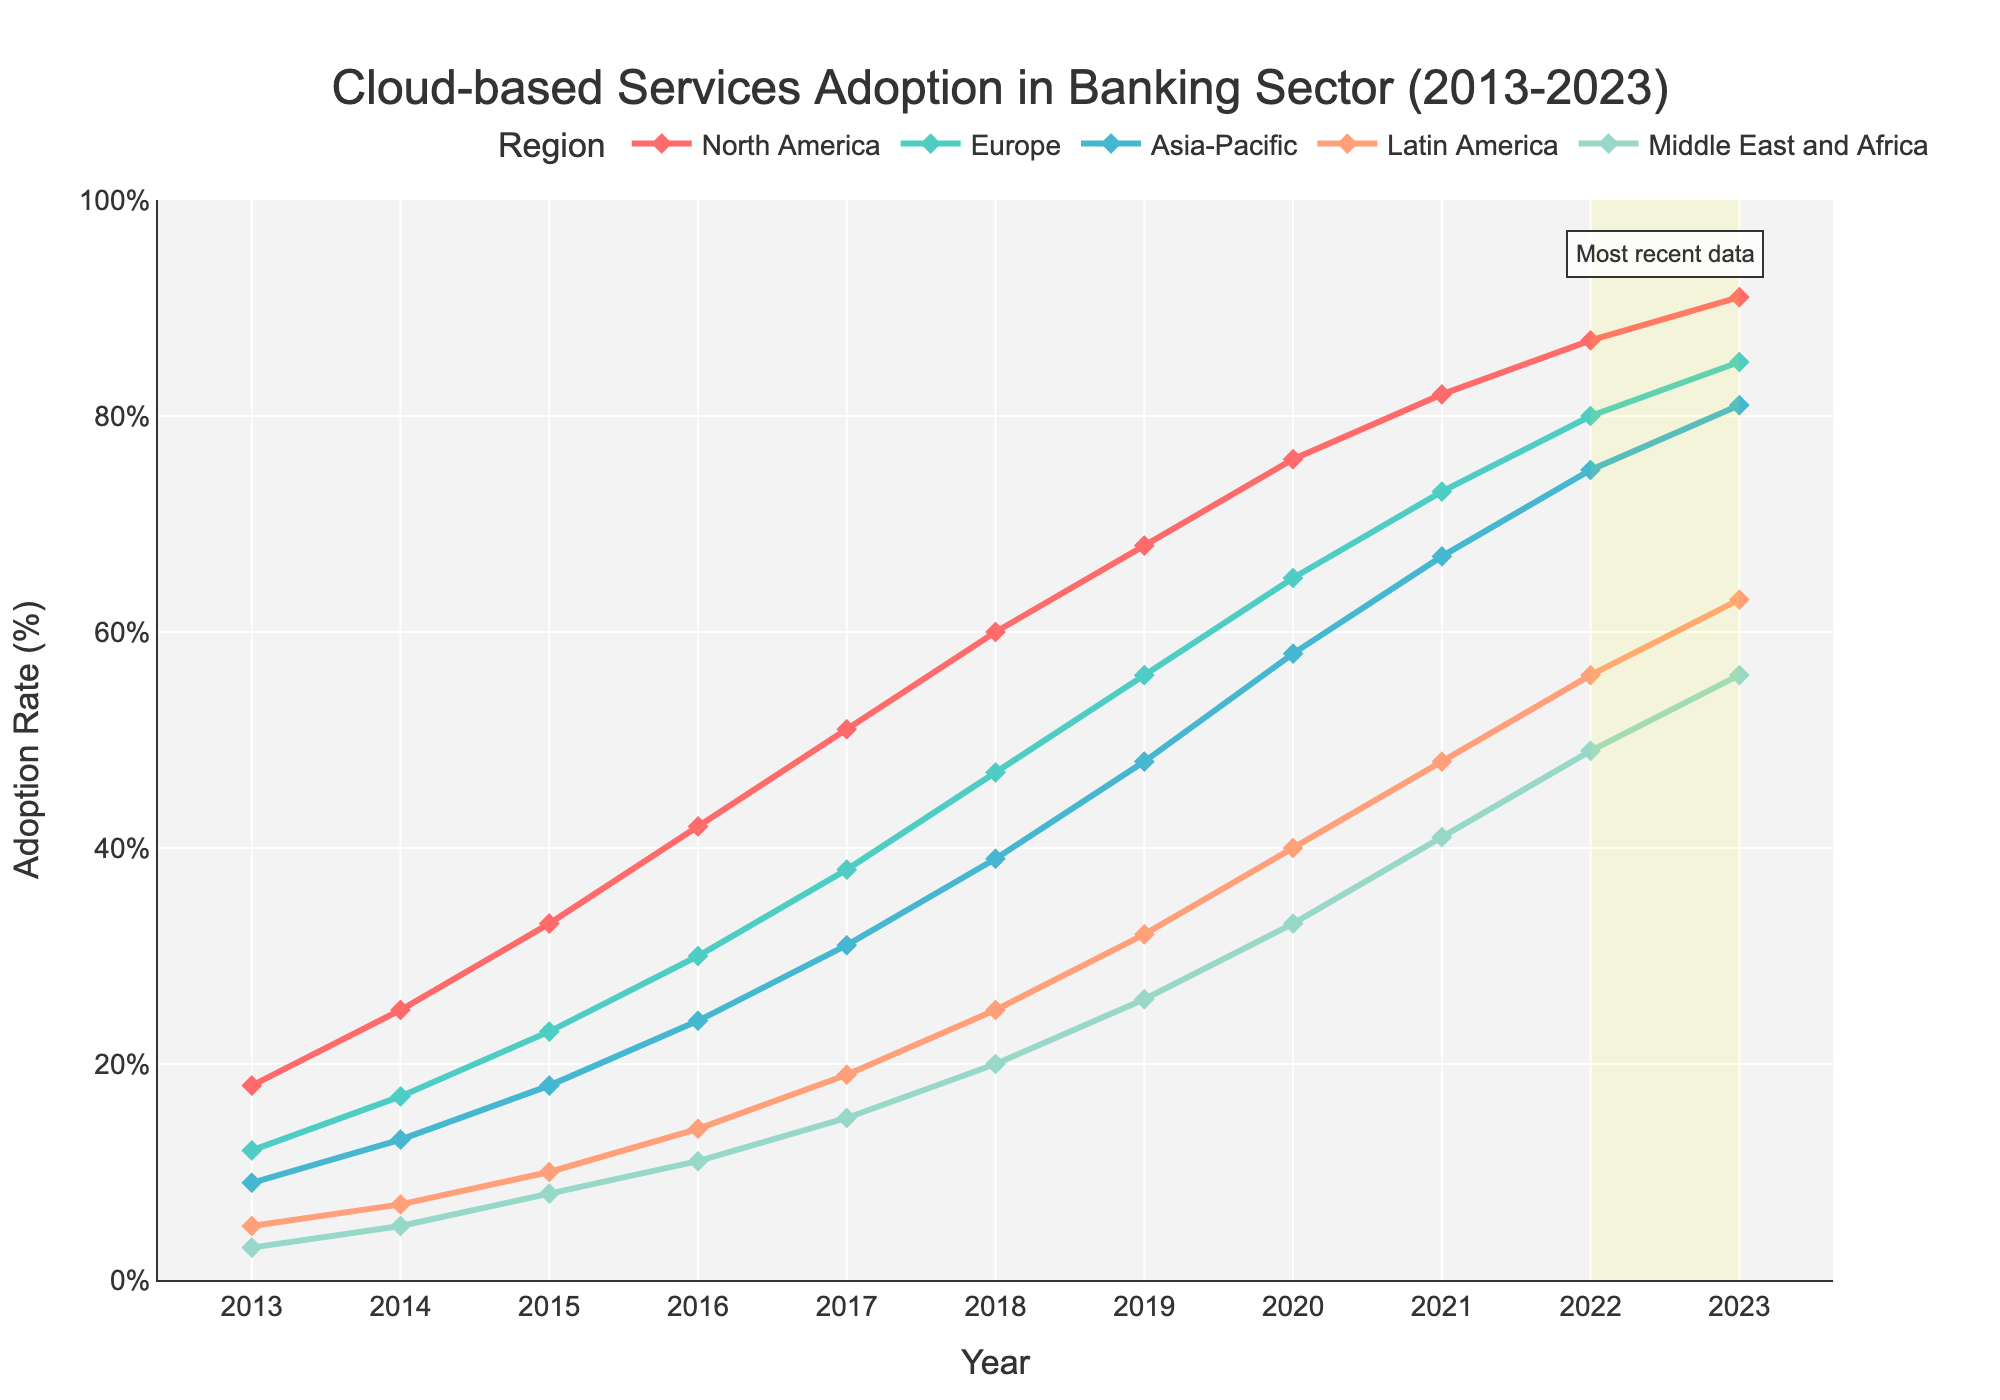Which region had the highest adoption rate of cloud-based services in 2023? First, identify the line that tops all others in 2023. According to the plot, North America's adoption rate is the highest at 91%.
Answer: North America What is the adoption rate difference between North America and Europe in 2017? Find the adoption rates for North America (51%) and Europe (38%) in 2017 and calculate the difference: 51 - 38 = 13%.
Answer: 13% Which region shows the steepest increase in adoption rates over the decade? Look for the region whose line has the steepest slope from 2013 to 2023. North America shows the most significant increase from 18% to 91%.
Answer: North America What is the combined adoption rate of the Asia-Pacific and Middle East and Africa in 2021? Identify the adoption rates for the Asia-Pacific (67%) and Middle East and Africa (41%) in 2021. Add them together: 67 + 41 = 108%.
Answer: 108% Has the adoption rate for cloud services in Europe consistently increased every year from 2013 to 2023? Check the line for Europe year by year; it shows a steady rise from 12% in 2013 to 85% in 2023 without any decline.
Answer: Yes By how much did Latin America's cloud services adoption rate grow from 2015 to 2023? Subtract the 2015 value (10%) from the 2023 value (63%): 63 - 10 = 53%.
Answer: 53% Which region's adoption rate surpassed 50% first? In which year did this happen? Look for the first instance when each region's adoption rate crossed 50%. North America is the first to surpass 50% in 2017.
Answer: North America, 2017 What is the average adoption rate for the Middle East and Africa over the decade? Sum the Middle East and Africa's rates from 2013 to 2023 (3 + 5 + 8 + 11 + 15 + 20 + 26 + 33 + 41 + 49 + 56 = 267). Divide by the number of years (11): 267 / 11 ≈ 24.27%.
Answer: 24.27% Which region has the lowest adoption rate in 2018, and what is that rate? Identify the lowest line in 2018, which corresponds to the Middle East and Africa at 20%.
Answer: Middle East and Africa, 20% How does the adoption rate for Latin America in 2023 compare to North America in 2016? Find the values: Latin America in 2023 is 63%, North America in 2016 is 42%. Compare them: 63% > 42%.
Answer: 63% > 42% 